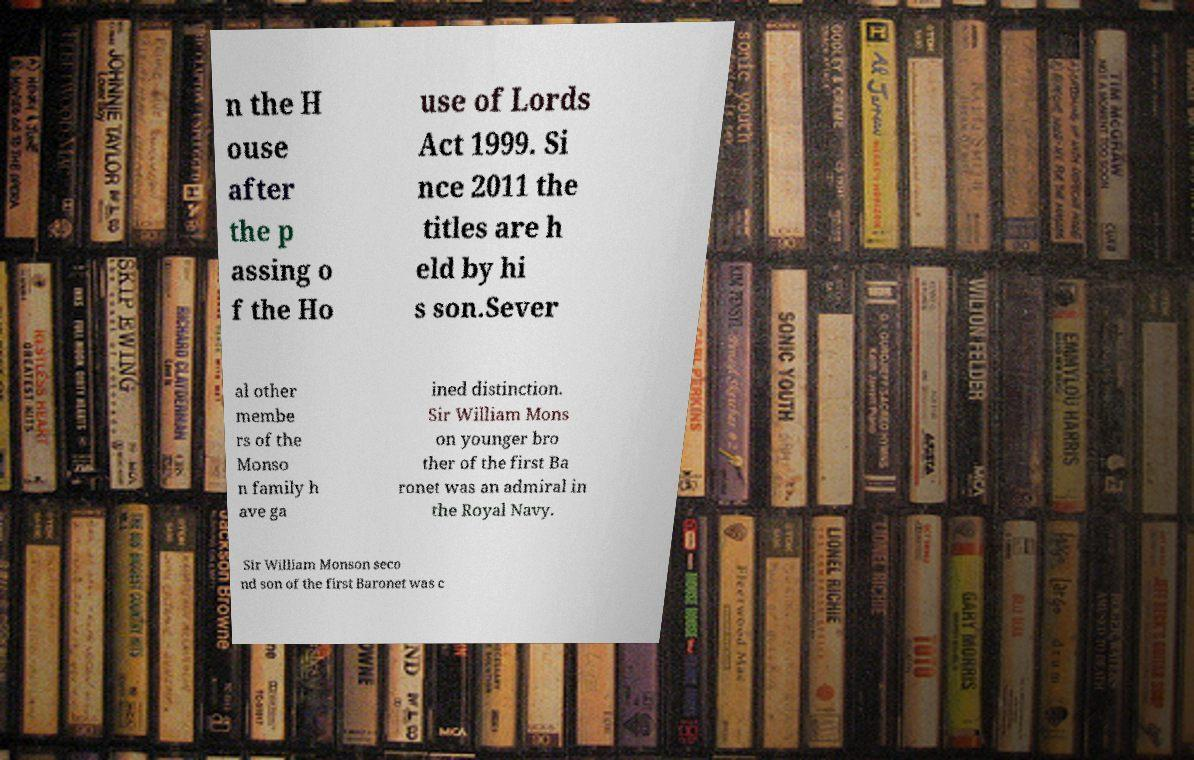I need the written content from this picture converted into text. Can you do that? n the H ouse after the p assing o f the Ho use of Lords Act 1999. Si nce 2011 the titles are h eld by hi s son.Sever al other membe rs of the Monso n family h ave ga ined distinction. Sir William Mons on younger bro ther of the first Ba ronet was an admiral in the Royal Navy. Sir William Monson seco nd son of the first Baronet was c 